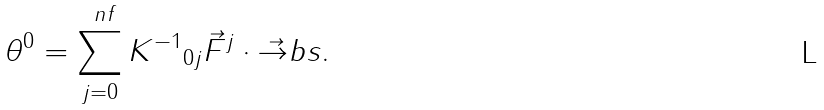<formula> <loc_0><loc_0><loc_500><loc_500>\theta ^ { 0 } = \sum _ { j = 0 } ^ { \ n f } { K ^ { - 1 } } _ { 0 j } \vec { F } ^ { j } \cdot \vec { \to } b s .</formula> 